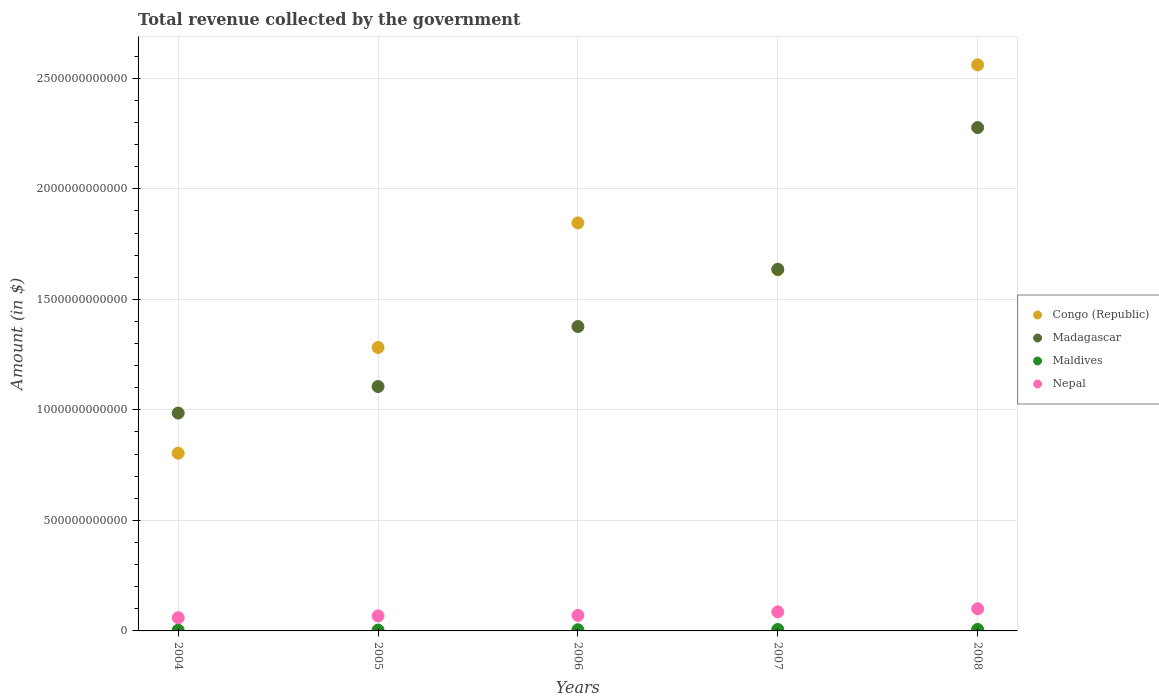How many different coloured dotlines are there?
Provide a succinct answer. 4. Is the number of dotlines equal to the number of legend labels?
Your answer should be very brief. Yes. What is the total revenue collected by the government in Madagascar in 2006?
Offer a terse response. 1.38e+12. Across all years, what is the maximum total revenue collected by the government in Nepal?
Offer a very short reply. 1.00e+11. Across all years, what is the minimum total revenue collected by the government in Madagascar?
Provide a short and direct response. 9.86e+11. In which year was the total revenue collected by the government in Madagascar maximum?
Offer a very short reply. 2008. What is the total total revenue collected by the government in Maldives in the graph?
Your answer should be compact. 2.57e+1. What is the difference between the total revenue collected by the government in Congo (Republic) in 2004 and that in 2008?
Provide a succinct answer. -1.76e+12. What is the difference between the total revenue collected by the government in Nepal in 2005 and the total revenue collected by the government in Maldives in 2007?
Keep it short and to the point. 6.16e+1. What is the average total revenue collected by the government in Nepal per year?
Your answer should be compact. 7.70e+1. In the year 2005, what is the difference between the total revenue collected by the government in Madagascar and total revenue collected by the government in Maldives?
Your response must be concise. 1.10e+12. What is the ratio of the total revenue collected by the government in Congo (Republic) in 2004 to that in 2007?
Offer a terse response. 0.49. Is the total revenue collected by the government in Madagascar in 2004 less than that in 2008?
Offer a very short reply. Yes. What is the difference between the highest and the second highest total revenue collected by the government in Maldives?
Give a very brief answer. 4.06e+08. What is the difference between the highest and the lowest total revenue collected by the government in Congo (Republic)?
Make the answer very short. 1.76e+12. In how many years, is the total revenue collected by the government in Nepal greater than the average total revenue collected by the government in Nepal taken over all years?
Your answer should be compact. 2. Is it the case that in every year, the sum of the total revenue collected by the government in Congo (Republic) and total revenue collected by the government in Madagascar  is greater than the sum of total revenue collected by the government in Maldives and total revenue collected by the government in Nepal?
Provide a short and direct response. Yes. Does the total revenue collected by the government in Maldives monotonically increase over the years?
Your answer should be compact. Yes. Is the total revenue collected by the government in Nepal strictly less than the total revenue collected by the government in Maldives over the years?
Keep it short and to the point. No. How many years are there in the graph?
Offer a terse response. 5. What is the difference between two consecutive major ticks on the Y-axis?
Your answer should be very brief. 5.00e+11. Does the graph contain any zero values?
Ensure brevity in your answer.  No. Does the graph contain grids?
Ensure brevity in your answer.  Yes. How many legend labels are there?
Offer a very short reply. 4. How are the legend labels stacked?
Your answer should be very brief. Vertical. What is the title of the graph?
Offer a very short reply. Total revenue collected by the government. Does "Belarus" appear as one of the legend labels in the graph?
Give a very brief answer. No. What is the label or title of the X-axis?
Give a very brief answer. Years. What is the label or title of the Y-axis?
Offer a terse response. Amount (in $). What is the Amount (in $) in Congo (Republic) in 2004?
Ensure brevity in your answer.  8.04e+11. What is the Amount (in $) in Madagascar in 2004?
Offer a terse response. 9.86e+11. What is the Amount (in $) of Maldives in 2004?
Your answer should be very brief. 3.33e+09. What is the Amount (in $) in Nepal in 2004?
Provide a succinct answer. 5.98e+1. What is the Amount (in $) of Congo (Republic) in 2005?
Provide a short and direct response. 1.28e+12. What is the Amount (in $) in Madagascar in 2005?
Offer a terse response. 1.11e+12. What is the Amount (in $) in Maldives in 2005?
Offer a very short reply. 3.75e+09. What is the Amount (in $) in Nepal in 2005?
Ensure brevity in your answer.  6.81e+1. What is the Amount (in $) in Congo (Republic) in 2006?
Offer a terse response. 1.85e+12. What is the Amount (in $) of Madagascar in 2006?
Offer a terse response. 1.38e+12. What is the Amount (in $) of Maldives in 2006?
Offer a very short reply. 5.24e+09. What is the Amount (in $) in Nepal in 2006?
Keep it short and to the point. 7.03e+1. What is the Amount (in $) of Congo (Republic) in 2007?
Provide a succinct answer. 1.63e+12. What is the Amount (in $) of Madagascar in 2007?
Keep it short and to the point. 1.64e+12. What is the Amount (in $) of Maldives in 2007?
Provide a succinct answer. 6.49e+09. What is the Amount (in $) of Nepal in 2007?
Give a very brief answer. 8.64e+1. What is the Amount (in $) of Congo (Republic) in 2008?
Provide a short and direct response. 2.56e+12. What is the Amount (in $) of Madagascar in 2008?
Give a very brief answer. 2.28e+12. What is the Amount (in $) in Maldives in 2008?
Make the answer very short. 6.90e+09. What is the Amount (in $) of Nepal in 2008?
Offer a terse response. 1.00e+11. Across all years, what is the maximum Amount (in $) of Congo (Republic)?
Provide a succinct answer. 2.56e+12. Across all years, what is the maximum Amount (in $) in Madagascar?
Give a very brief answer. 2.28e+12. Across all years, what is the maximum Amount (in $) in Maldives?
Provide a succinct answer. 6.90e+09. Across all years, what is the maximum Amount (in $) of Nepal?
Make the answer very short. 1.00e+11. Across all years, what is the minimum Amount (in $) of Congo (Republic)?
Your answer should be compact. 8.04e+11. Across all years, what is the minimum Amount (in $) of Madagascar?
Your response must be concise. 9.86e+11. Across all years, what is the minimum Amount (in $) of Maldives?
Offer a very short reply. 3.33e+09. Across all years, what is the minimum Amount (in $) of Nepal?
Offer a very short reply. 5.98e+1. What is the total Amount (in $) of Congo (Republic) in the graph?
Offer a terse response. 8.13e+12. What is the total Amount (in $) in Madagascar in the graph?
Your response must be concise. 7.38e+12. What is the total Amount (in $) in Maldives in the graph?
Your answer should be compact. 2.57e+1. What is the total Amount (in $) in Nepal in the graph?
Your answer should be compact. 3.85e+11. What is the difference between the Amount (in $) of Congo (Republic) in 2004 and that in 2005?
Give a very brief answer. -4.78e+11. What is the difference between the Amount (in $) in Madagascar in 2004 and that in 2005?
Give a very brief answer. -1.20e+11. What is the difference between the Amount (in $) in Maldives in 2004 and that in 2005?
Your answer should be very brief. -4.22e+08. What is the difference between the Amount (in $) of Nepal in 2004 and that in 2005?
Provide a short and direct response. -8.28e+09. What is the difference between the Amount (in $) in Congo (Republic) in 2004 and that in 2006?
Make the answer very short. -1.04e+12. What is the difference between the Amount (in $) in Madagascar in 2004 and that in 2006?
Provide a succinct answer. -3.91e+11. What is the difference between the Amount (in $) in Maldives in 2004 and that in 2006?
Your response must be concise. -1.91e+09. What is the difference between the Amount (in $) in Nepal in 2004 and that in 2006?
Keep it short and to the point. -1.05e+1. What is the difference between the Amount (in $) of Congo (Republic) in 2004 and that in 2007?
Your answer should be very brief. -8.29e+11. What is the difference between the Amount (in $) of Madagascar in 2004 and that in 2007?
Keep it short and to the point. -6.50e+11. What is the difference between the Amount (in $) in Maldives in 2004 and that in 2007?
Your answer should be very brief. -3.16e+09. What is the difference between the Amount (in $) in Nepal in 2004 and that in 2007?
Your response must be concise. -2.66e+1. What is the difference between the Amount (in $) in Congo (Republic) in 2004 and that in 2008?
Make the answer very short. -1.76e+12. What is the difference between the Amount (in $) of Madagascar in 2004 and that in 2008?
Ensure brevity in your answer.  -1.29e+12. What is the difference between the Amount (in $) of Maldives in 2004 and that in 2008?
Make the answer very short. -3.57e+09. What is the difference between the Amount (in $) of Nepal in 2004 and that in 2008?
Your answer should be very brief. -4.05e+1. What is the difference between the Amount (in $) of Congo (Republic) in 2005 and that in 2006?
Offer a very short reply. -5.64e+11. What is the difference between the Amount (in $) in Madagascar in 2005 and that in 2006?
Your answer should be very brief. -2.72e+11. What is the difference between the Amount (in $) of Maldives in 2005 and that in 2006?
Ensure brevity in your answer.  -1.48e+09. What is the difference between the Amount (in $) in Nepal in 2005 and that in 2006?
Give a very brief answer. -2.21e+09. What is the difference between the Amount (in $) in Congo (Republic) in 2005 and that in 2007?
Offer a terse response. -3.51e+11. What is the difference between the Amount (in $) of Madagascar in 2005 and that in 2007?
Offer a very short reply. -5.30e+11. What is the difference between the Amount (in $) of Maldives in 2005 and that in 2007?
Ensure brevity in your answer.  -2.74e+09. What is the difference between the Amount (in $) of Nepal in 2005 and that in 2007?
Offer a very short reply. -1.83e+1. What is the difference between the Amount (in $) of Congo (Republic) in 2005 and that in 2008?
Make the answer very short. -1.28e+12. What is the difference between the Amount (in $) in Madagascar in 2005 and that in 2008?
Your answer should be very brief. -1.17e+12. What is the difference between the Amount (in $) in Maldives in 2005 and that in 2008?
Offer a very short reply. -3.14e+09. What is the difference between the Amount (in $) in Nepal in 2005 and that in 2008?
Your answer should be very brief. -3.23e+1. What is the difference between the Amount (in $) in Congo (Republic) in 2006 and that in 2007?
Ensure brevity in your answer.  2.12e+11. What is the difference between the Amount (in $) of Madagascar in 2006 and that in 2007?
Your answer should be very brief. -2.59e+11. What is the difference between the Amount (in $) of Maldives in 2006 and that in 2007?
Keep it short and to the point. -1.25e+09. What is the difference between the Amount (in $) in Nepal in 2006 and that in 2007?
Your answer should be compact. -1.61e+1. What is the difference between the Amount (in $) in Congo (Republic) in 2006 and that in 2008?
Your response must be concise. -7.15e+11. What is the difference between the Amount (in $) in Madagascar in 2006 and that in 2008?
Offer a terse response. -9.00e+11. What is the difference between the Amount (in $) in Maldives in 2006 and that in 2008?
Keep it short and to the point. -1.66e+09. What is the difference between the Amount (in $) of Nepal in 2006 and that in 2008?
Your answer should be compact. -3.01e+1. What is the difference between the Amount (in $) of Congo (Republic) in 2007 and that in 2008?
Keep it short and to the point. -9.27e+11. What is the difference between the Amount (in $) of Madagascar in 2007 and that in 2008?
Ensure brevity in your answer.  -6.41e+11. What is the difference between the Amount (in $) in Maldives in 2007 and that in 2008?
Your answer should be compact. -4.06e+08. What is the difference between the Amount (in $) in Nepal in 2007 and that in 2008?
Give a very brief answer. -1.39e+1. What is the difference between the Amount (in $) in Congo (Republic) in 2004 and the Amount (in $) in Madagascar in 2005?
Provide a succinct answer. -3.01e+11. What is the difference between the Amount (in $) of Congo (Republic) in 2004 and the Amount (in $) of Maldives in 2005?
Offer a terse response. 8.00e+11. What is the difference between the Amount (in $) of Congo (Republic) in 2004 and the Amount (in $) of Nepal in 2005?
Make the answer very short. 7.36e+11. What is the difference between the Amount (in $) of Madagascar in 2004 and the Amount (in $) of Maldives in 2005?
Offer a terse response. 9.82e+11. What is the difference between the Amount (in $) of Madagascar in 2004 and the Amount (in $) of Nepal in 2005?
Provide a succinct answer. 9.18e+11. What is the difference between the Amount (in $) of Maldives in 2004 and the Amount (in $) of Nepal in 2005?
Keep it short and to the point. -6.47e+1. What is the difference between the Amount (in $) of Congo (Republic) in 2004 and the Amount (in $) of Madagascar in 2006?
Provide a succinct answer. -5.73e+11. What is the difference between the Amount (in $) in Congo (Republic) in 2004 and the Amount (in $) in Maldives in 2006?
Offer a very short reply. 7.99e+11. What is the difference between the Amount (in $) in Congo (Republic) in 2004 and the Amount (in $) in Nepal in 2006?
Offer a very short reply. 7.34e+11. What is the difference between the Amount (in $) in Madagascar in 2004 and the Amount (in $) in Maldives in 2006?
Offer a terse response. 9.80e+11. What is the difference between the Amount (in $) in Madagascar in 2004 and the Amount (in $) in Nepal in 2006?
Your answer should be compact. 9.15e+11. What is the difference between the Amount (in $) of Maldives in 2004 and the Amount (in $) of Nepal in 2006?
Provide a short and direct response. -6.69e+1. What is the difference between the Amount (in $) in Congo (Republic) in 2004 and the Amount (in $) in Madagascar in 2007?
Offer a terse response. -8.32e+11. What is the difference between the Amount (in $) of Congo (Republic) in 2004 and the Amount (in $) of Maldives in 2007?
Your answer should be compact. 7.98e+11. What is the difference between the Amount (in $) of Congo (Republic) in 2004 and the Amount (in $) of Nepal in 2007?
Provide a short and direct response. 7.18e+11. What is the difference between the Amount (in $) in Madagascar in 2004 and the Amount (in $) in Maldives in 2007?
Provide a short and direct response. 9.79e+11. What is the difference between the Amount (in $) in Madagascar in 2004 and the Amount (in $) in Nepal in 2007?
Ensure brevity in your answer.  8.99e+11. What is the difference between the Amount (in $) in Maldives in 2004 and the Amount (in $) in Nepal in 2007?
Your answer should be compact. -8.31e+1. What is the difference between the Amount (in $) of Congo (Republic) in 2004 and the Amount (in $) of Madagascar in 2008?
Provide a short and direct response. -1.47e+12. What is the difference between the Amount (in $) in Congo (Republic) in 2004 and the Amount (in $) in Maldives in 2008?
Offer a terse response. 7.97e+11. What is the difference between the Amount (in $) of Congo (Republic) in 2004 and the Amount (in $) of Nepal in 2008?
Make the answer very short. 7.04e+11. What is the difference between the Amount (in $) in Madagascar in 2004 and the Amount (in $) in Maldives in 2008?
Offer a very short reply. 9.79e+11. What is the difference between the Amount (in $) of Madagascar in 2004 and the Amount (in $) of Nepal in 2008?
Provide a short and direct response. 8.85e+11. What is the difference between the Amount (in $) in Maldives in 2004 and the Amount (in $) in Nepal in 2008?
Your answer should be very brief. -9.70e+1. What is the difference between the Amount (in $) in Congo (Republic) in 2005 and the Amount (in $) in Madagascar in 2006?
Your answer should be very brief. -9.48e+1. What is the difference between the Amount (in $) in Congo (Republic) in 2005 and the Amount (in $) in Maldives in 2006?
Your answer should be compact. 1.28e+12. What is the difference between the Amount (in $) in Congo (Republic) in 2005 and the Amount (in $) in Nepal in 2006?
Provide a short and direct response. 1.21e+12. What is the difference between the Amount (in $) in Madagascar in 2005 and the Amount (in $) in Maldives in 2006?
Your response must be concise. 1.10e+12. What is the difference between the Amount (in $) of Madagascar in 2005 and the Amount (in $) of Nepal in 2006?
Provide a succinct answer. 1.04e+12. What is the difference between the Amount (in $) in Maldives in 2005 and the Amount (in $) in Nepal in 2006?
Offer a very short reply. -6.65e+1. What is the difference between the Amount (in $) of Congo (Republic) in 2005 and the Amount (in $) of Madagascar in 2007?
Offer a terse response. -3.54e+11. What is the difference between the Amount (in $) in Congo (Republic) in 2005 and the Amount (in $) in Maldives in 2007?
Provide a succinct answer. 1.28e+12. What is the difference between the Amount (in $) in Congo (Republic) in 2005 and the Amount (in $) in Nepal in 2007?
Offer a very short reply. 1.20e+12. What is the difference between the Amount (in $) in Madagascar in 2005 and the Amount (in $) in Maldives in 2007?
Offer a terse response. 1.10e+12. What is the difference between the Amount (in $) of Madagascar in 2005 and the Amount (in $) of Nepal in 2007?
Ensure brevity in your answer.  1.02e+12. What is the difference between the Amount (in $) of Maldives in 2005 and the Amount (in $) of Nepal in 2007?
Offer a terse response. -8.26e+1. What is the difference between the Amount (in $) in Congo (Republic) in 2005 and the Amount (in $) in Madagascar in 2008?
Offer a terse response. -9.95e+11. What is the difference between the Amount (in $) in Congo (Republic) in 2005 and the Amount (in $) in Maldives in 2008?
Your answer should be compact. 1.28e+12. What is the difference between the Amount (in $) of Congo (Republic) in 2005 and the Amount (in $) of Nepal in 2008?
Your answer should be very brief. 1.18e+12. What is the difference between the Amount (in $) of Madagascar in 2005 and the Amount (in $) of Maldives in 2008?
Your answer should be compact. 1.10e+12. What is the difference between the Amount (in $) in Madagascar in 2005 and the Amount (in $) in Nepal in 2008?
Give a very brief answer. 1.01e+12. What is the difference between the Amount (in $) in Maldives in 2005 and the Amount (in $) in Nepal in 2008?
Give a very brief answer. -9.66e+1. What is the difference between the Amount (in $) of Congo (Republic) in 2006 and the Amount (in $) of Madagascar in 2007?
Provide a short and direct response. 2.10e+11. What is the difference between the Amount (in $) of Congo (Republic) in 2006 and the Amount (in $) of Maldives in 2007?
Give a very brief answer. 1.84e+12. What is the difference between the Amount (in $) of Congo (Republic) in 2006 and the Amount (in $) of Nepal in 2007?
Make the answer very short. 1.76e+12. What is the difference between the Amount (in $) in Madagascar in 2006 and the Amount (in $) in Maldives in 2007?
Keep it short and to the point. 1.37e+12. What is the difference between the Amount (in $) of Madagascar in 2006 and the Amount (in $) of Nepal in 2007?
Your response must be concise. 1.29e+12. What is the difference between the Amount (in $) of Maldives in 2006 and the Amount (in $) of Nepal in 2007?
Ensure brevity in your answer.  -8.11e+1. What is the difference between the Amount (in $) of Congo (Republic) in 2006 and the Amount (in $) of Madagascar in 2008?
Your answer should be very brief. -4.31e+11. What is the difference between the Amount (in $) of Congo (Republic) in 2006 and the Amount (in $) of Maldives in 2008?
Your answer should be compact. 1.84e+12. What is the difference between the Amount (in $) in Congo (Republic) in 2006 and the Amount (in $) in Nepal in 2008?
Your answer should be very brief. 1.75e+12. What is the difference between the Amount (in $) in Madagascar in 2006 and the Amount (in $) in Maldives in 2008?
Give a very brief answer. 1.37e+12. What is the difference between the Amount (in $) of Madagascar in 2006 and the Amount (in $) of Nepal in 2008?
Make the answer very short. 1.28e+12. What is the difference between the Amount (in $) in Maldives in 2006 and the Amount (in $) in Nepal in 2008?
Offer a terse response. -9.51e+1. What is the difference between the Amount (in $) of Congo (Republic) in 2007 and the Amount (in $) of Madagascar in 2008?
Make the answer very short. -6.44e+11. What is the difference between the Amount (in $) of Congo (Republic) in 2007 and the Amount (in $) of Maldives in 2008?
Your answer should be compact. 1.63e+12. What is the difference between the Amount (in $) of Congo (Republic) in 2007 and the Amount (in $) of Nepal in 2008?
Provide a short and direct response. 1.53e+12. What is the difference between the Amount (in $) in Madagascar in 2007 and the Amount (in $) in Maldives in 2008?
Keep it short and to the point. 1.63e+12. What is the difference between the Amount (in $) in Madagascar in 2007 and the Amount (in $) in Nepal in 2008?
Your answer should be very brief. 1.54e+12. What is the difference between the Amount (in $) of Maldives in 2007 and the Amount (in $) of Nepal in 2008?
Provide a succinct answer. -9.38e+1. What is the average Amount (in $) in Congo (Republic) per year?
Make the answer very short. 1.63e+12. What is the average Amount (in $) of Madagascar per year?
Offer a terse response. 1.48e+12. What is the average Amount (in $) in Maldives per year?
Offer a very short reply. 5.14e+09. What is the average Amount (in $) in Nepal per year?
Give a very brief answer. 7.70e+1. In the year 2004, what is the difference between the Amount (in $) in Congo (Republic) and Amount (in $) in Madagascar?
Your response must be concise. -1.82e+11. In the year 2004, what is the difference between the Amount (in $) of Congo (Republic) and Amount (in $) of Maldives?
Offer a very short reply. 8.01e+11. In the year 2004, what is the difference between the Amount (in $) in Congo (Republic) and Amount (in $) in Nepal?
Give a very brief answer. 7.44e+11. In the year 2004, what is the difference between the Amount (in $) of Madagascar and Amount (in $) of Maldives?
Provide a short and direct response. 9.82e+11. In the year 2004, what is the difference between the Amount (in $) in Madagascar and Amount (in $) in Nepal?
Give a very brief answer. 9.26e+11. In the year 2004, what is the difference between the Amount (in $) in Maldives and Amount (in $) in Nepal?
Ensure brevity in your answer.  -5.64e+1. In the year 2005, what is the difference between the Amount (in $) in Congo (Republic) and Amount (in $) in Madagascar?
Your response must be concise. 1.77e+11. In the year 2005, what is the difference between the Amount (in $) of Congo (Republic) and Amount (in $) of Maldives?
Your answer should be compact. 1.28e+12. In the year 2005, what is the difference between the Amount (in $) of Congo (Republic) and Amount (in $) of Nepal?
Offer a terse response. 1.21e+12. In the year 2005, what is the difference between the Amount (in $) in Madagascar and Amount (in $) in Maldives?
Keep it short and to the point. 1.10e+12. In the year 2005, what is the difference between the Amount (in $) of Madagascar and Amount (in $) of Nepal?
Your answer should be very brief. 1.04e+12. In the year 2005, what is the difference between the Amount (in $) in Maldives and Amount (in $) in Nepal?
Provide a succinct answer. -6.43e+1. In the year 2006, what is the difference between the Amount (in $) of Congo (Republic) and Amount (in $) of Madagascar?
Provide a succinct answer. 4.69e+11. In the year 2006, what is the difference between the Amount (in $) of Congo (Republic) and Amount (in $) of Maldives?
Provide a short and direct response. 1.84e+12. In the year 2006, what is the difference between the Amount (in $) in Congo (Republic) and Amount (in $) in Nepal?
Ensure brevity in your answer.  1.78e+12. In the year 2006, what is the difference between the Amount (in $) in Madagascar and Amount (in $) in Maldives?
Your answer should be compact. 1.37e+12. In the year 2006, what is the difference between the Amount (in $) of Madagascar and Amount (in $) of Nepal?
Your answer should be very brief. 1.31e+12. In the year 2006, what is the difference between the Amount (in $) in Maldives and Amount (in $) in Nepal?
Keep it short and to the point. -6.50e+1. In the year 2007, what is the difference between the Amount (in $) of Congo (Republic) and Amount (in $) of Madagascar?
Provide a succinct answer. -2.47e+09. In the year 2007, what is the difference between the Amount (in $) in Congo (Republic) and Amount (in $) in Maldives?
Your answer should be very brief. 1.63e+12. In the year 2007, what is the difference between the Amount (in $) in Congo (Republic) and Amount (in $) in Nepal?
Your answer should be compact. 1.55e+12. In the year 2007, what is the difference between the Amount (in $) of Madagascar and Amount (in $) of Maldives?
Give a very brief answer. 1.63e+12. In the year 2007, what is the difference between the Amount (in $) of Madagascar and Amount (in $) of Nepal?
Offer a very short reply. 1.55e+12. In the year 2007, what is the difference between the Amount (in $) in Maldives and Amount (in $) in Nepal?
Your answer should be very brief. -7.99e+1. In the year 2008, what is the difference between the Amount (in $) of Congo (Republic) and Amount (in $) of Madagascar?
Ensure brevity in your answer.  2.84e+11. In the year 2008, what is the difference between the Amount (in $) in Congo (Republic) and Amount (in $) in Maldives?
Your answer should be compact. 2.55e+12. In the year 2008, what is the difference between the Amount (in $) of Congo (Republic) and Amount (in $) of Nepal?
Give a very brief answer. 2.46e+12. In the year 2008, what is the difference between the Amount (in $) in Madagascar and Amount (in $) in Maldives?
Keep it short and to the point. 2.27e+12. In the year 2008, what is the difference between the Amount (in $) of Madagascar and Amount (in $) of Nepal?
Give a very brief answer. 2.18e+12. In the year 2008, what is the difference between the Amount (in $) of Maldives and Amount (in $) of Nepal?
Provide a succinct answer. -9.34e+1. What is the ratio of the Amount (in $) in Congo (Republic) in 2004 to that in 2005?
Offer a terse response. 0.63. What is the ratio of the Amount (in $) in Madagascar in 2004 to that in 2005?
Provide a short and direct response. 0.89. What is the ratio of the Amount (in $) in Maldives in 2004 to that in 2005?
Offer a terse response. 0.89. What is the ratio of the Amount (in $) of Nepal in 2004 to that in 2005?
Offer a very short reply. 0.88. What is the ratio of the Amount (in $) in Congo (Republic) in 2004 to that in 2006?
Keep it short and to the point. 0.44. What is the ratio of the Amount (in $) in Madagascar in 2004 to that in 2006?
Ensure brevity in your answer.  0.72. What is the ratio of the Amount (in $) of Maldives in 2004 to that in 2006?
Ensure brevity in your answer.  0.64. What is the ratio of the Amount (in $) in Nepal in 2004 to that in 2006?
Make the answer very short. 0.85. What is the ratio of the Amount (in $) in Congo (Republic) in 2004 to that in 2007?
Ensure brevity in your answer.  0.49. What is the ratio of the Amount (in $) in Madagascar in 2004 to that in 2007?
Keep it short and to the point. 0.6. What is the ratio of the Amount (in $) of Maldives in 2004 to that in 2007?
Give a very brief answer. 0.51. What is the ratio of the Amount (in $) of Nepal in 2004 to that in 2007?
Offer a terse response. 0.69. What is the ratio of the Amount (in $) in Congo (Republic) in 2004 to that in 2008?
Give a very brief answer. 0.31. What is the ratio of the Amount (in $) in Madagascar in 2004 to that in 2008?
Offer a terse response. 0.43. What is the ratio of the Amount (in $) of Maldives in 2004 to that in 2008?
Offer a terse response. 0.48. What is the ratio of the Amount (in $) of Nepal in 2004 to that in 2008?
Provide a succinct answer. 0.6. What is the ratio of the Amount (in $) in Congo (Republic) in 2005 to that in 2006?
Offer a very short reply. 0.69. What is the ratio of the Amount (in $) of Madagascar in 2005 to that in 2006?
Provide a succinct answer. 0.8. What is the ratio of the Amount (in $) in Maldives in 2005 to that in 2006?
Your response must be concise. 0.72. What is the ratio of the Amount (in $) in Nepal in 2005 to that in 2006?
Keep it short and to the point. 0.97. What is the ratio of the Amount (in $) of Congo (Republic) in 2005 to that in 2007?
Ensure brevity in your answer.  0.78. What is the ratio of the Amount (in $) in Madagascar in 2005 to that in 2007?
Ensure brevity in your answer.  0.68. What is the ratio of the Amount (in $) in Maldives in 2005 to that in 2007?
Keep it short and to the point. 0.58. What is the ratio of the Amount (in $) in Nepal in 2005 to that in 2007?
Provide a succinct answer. 0.79. What is the ratio of the Amount (in $) of Congo (Republic) in 2005 to that in 2008?
Offer a very short reply. 0.5. What is the ratio of the Amount (in $) of Madagascar in 2005 to that in 2008?
Your response must be concise. 0.49. What is the ratio of the Amount (in $) of Maldives in 2005 to that in 2008?
Ensure brevity in your answer.  0.54. What is the ratio of the Amount (in $) in Nepal in 2005 to that in 2008?
Your answer should be very brief. 0.68. What is the ratio of the Amount (in $) in Congo (Republic) in 2006 to that in 2007?
Your answer should be very brief. 1.13. What is the ratio of the Amount (in $) of Madagascar in 2006 to that in 2007?
Offer a terse response. 0.84. What is the ratio of the Amount (in $) in Maldives in 2006 to that in 2007?
Your response must be concise. 0.81. What is the ratio of the Amount (in $) of Nepal in 2006 to that in 2007?
Your answer should be very brief. 0.81. What is the ratio of the Amount (in $) of Congo (Republic) in 2006 to that in 2008?
Offer a terse response. 0.72. What is the ratio of the Amount (in $) of Madagascar in 2006 to that in 2008?
Make the answer very short. 0.6. What is the ratio of the Amount (in $) in Maldives in 2006 to that in 2008?
Offer a terse response. 0.76. What is the ratio of the Amount (in $) of Nepal in 2006 to that in 2008?
Offer a terse response. 0.7. What is the ratio of the Amount (in $) of Congo (Republic) in 2007 to that in 2008?
Make the answer very short. 0.64. What is the ratio of the Amount (in $) in Madagascar in 2007 to that in 2008?
Your answer should be compact. 0.72. What is the ratio of the Amount (in $) in Maldives in 2007 to that in 2008?
Give a very brief answer. 0.94. What is the ratio of the Amount (in $) of Nepal in 2007 to that in 2008?
Offer a terse response. 0.86. What is the difference between the highest and the second highest Amount (in $) in Congo (Republic)?
Offer a very short reply. 7.15e+11. What is the difference between the highest and the second highest Amount (in $) of Madagascar?
Provide a succinct answer. 6.41e+11. What is the difference between the highest and the second highest Amount (in $) in Maldives?
Provide a short and direct response. 4.06e+08. What is the difference between the highest and the second highest Amount (in $) in Nepal?
Make the answer very short. 1.39e+1. What is the difference between the highest and the lowest Amount (in $) in Congo (Republic)?
Ensure brevity in your answer.  1.76e+12. What is the difference between the highest and the lowest Amount (in $) of Madagascar?
Offer a very short reply. 1.29e+12. What is the difference between the highest and the lowest Amount (in $) in Maldives?
Your answer should be compact. 3.57e+09. What is the difference between the highest and the lowest Amount (in $) in Nepal?
Give a very brief answer. 4.05e+1. 